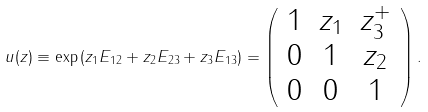Convert formula to latex. <formula><loc_0><loc_0><loc_500><loc_500>u ( z ) \equiv \exp \left ( z _ { 1 } E _ { 1 2 } + z _ { 2 } E _ { 2 3 } + z _ { 3 } E _ { 1 3 } \right ) = \left ( \begin{array} { c c c } 1 & z _ { 1 } & z ^ { + } _ { 3 } \\ 0 & 1 & z _ { 2 } \\ 0 & 0 & 1 \end{array} \right ) .</formula> 